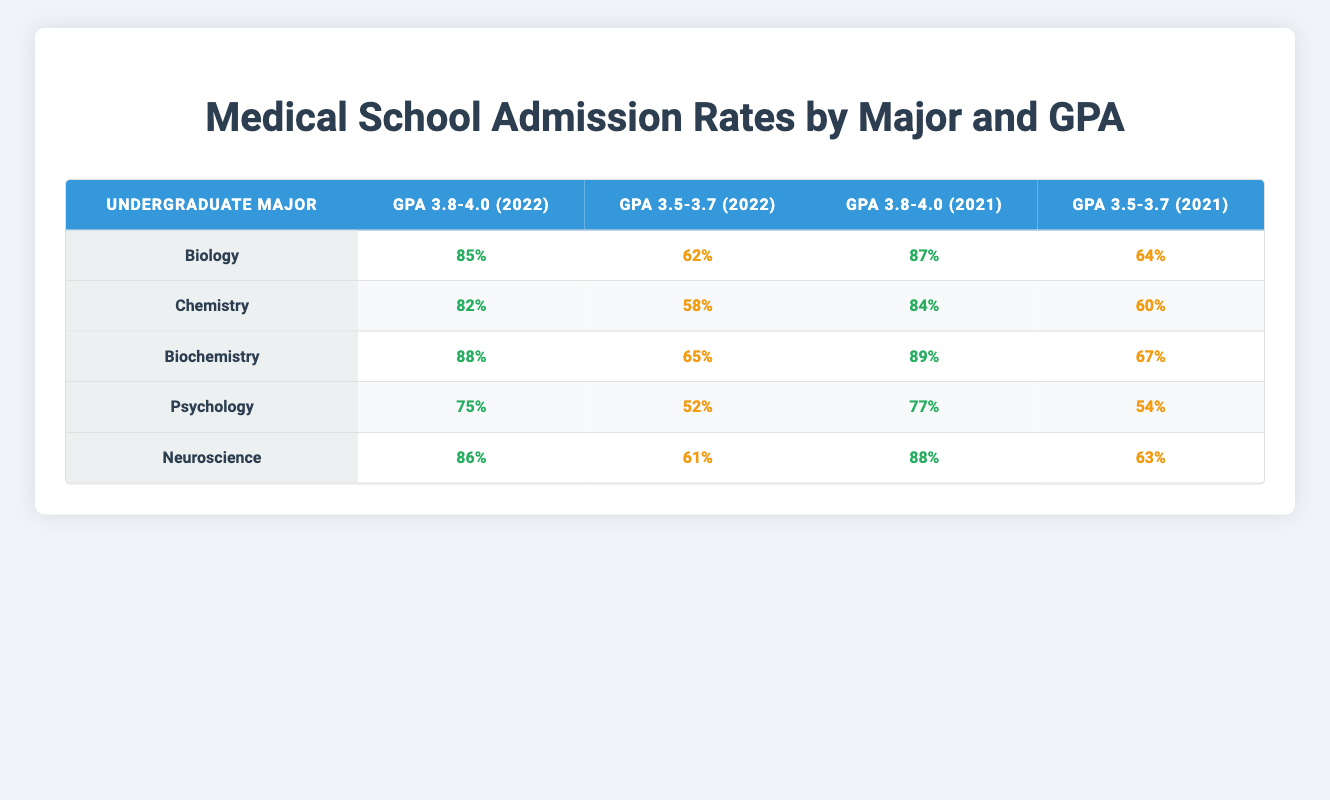What is the highest admission rate in 2022 for students with a GPA between 3.8 and 4.0? The highest admission rate for this GPA range in 2022 is found by looking at the "GPA 3.8-4.0 (2022)" column. The highest value is 88% for Biochemistry.
Answer: 88% Which undergraduate major had the lowest admission rate for the GPA range of 3.5-3.7 in 2021? I need to compare the admission rates in the "GPA 3.5-3.7 (2021)" column. The minimum value among them is 54% for Psychology.
Answer: 54% What is the average admission rate for Neuroscience across both years in the table? To find the average, I take the admission rates for Neuroscience: 86% (2022, GPA 3.8-4.0), 61% (2022, GPA 3.5-3.7), 88% (2021, GPA 3.8-4.0), and 63% (2021, GPA 3.5-3.7). The sum is 86 + 61 + 88 + 63 = 298, and since there are 4 entries, the average is 298 / 4 = 74.5%.
Answer: 74.5% Is it true that a Biology major has a better admission rate than a Psychology major for a GPA of 3.8-4.0 in both years? I check the Biology and Psychology admission rates for the ranges 3.8-4.0 for both years: Biology had 85% (2022) and 87% (2021) while Psychology had 75% (2022) and 77% (2021). So, the statement is true.
Answer: Yes What is the difference in admission rates between Biochemistry and Chemistry for the GPA range of 3.8-4.0 in 2021? I check the "GPA 3.8-4.0 (2021)" column for both majors: Biochemistry has an admission rate of 89% and Chemistry has 84%. So, I find the difference: 89 - 84 = 5%.
Answer: 5% 